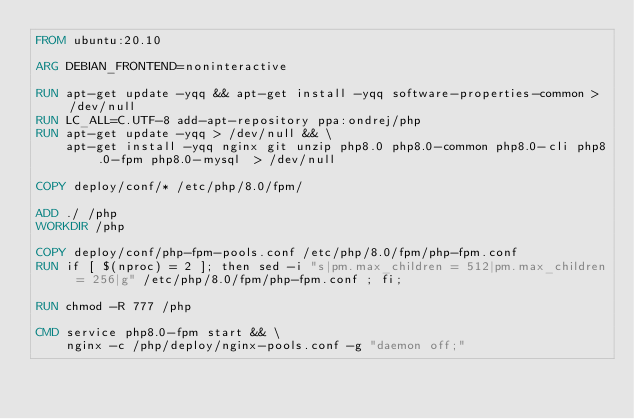<code> <loc_0><loc_0><loc_500><loc_500><_Dockerfile_>FROM ubuntu:20.10

ARG DEBIAN_FRONTEND=noninteractive

RUN apt-get update -yqq && apt-get install -yqq software-properties-common > /dev/null
RUN LC_ALL=C.UTF-8 add-apt-repository ppa:ondrej/php
RUN apt-get update -yqq > /dev/null && \
    apt-get install -yqq nginx git unzip php8.0 php8.0-common php8.0-cli php8.0-fpm php8.0-mysql  > /dev/null

COPY deploy/conf/* /etc/php/8.0/fpm/

ADD ./ /php
WORKDIR /php

COPY deploy/conf/php-fpm-pools.conf /etc/php/8.0/fpm/php-fpm.conf
RUN if [ $(nproc) = 2 ]; then sed -i "s|pm.max_children = 512|pm.max_children = 256|g" /etc/php/8.0/fpm/php-fpm.conf ; fi;

RUN chmod -R 777 /php

CMD service php8.0-fpm start && \
    nginx -c /php/deploy/nginx-pools.conf -g "daemon off;"
</code> 